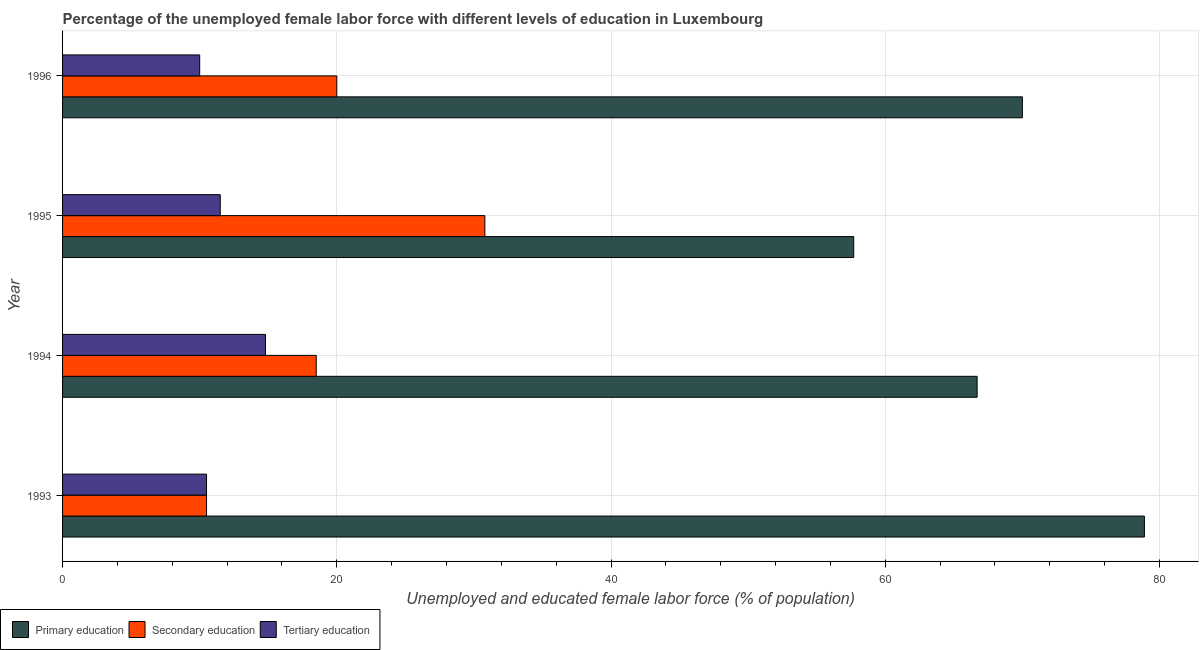How many groups of bars are there?
Offer a terse response. 4. How many bars are there on the 3rd tick from the bottom?
Keep it short and to the point. 3. What is the label of the 2nd group of bars from the top?
Give a very brief answer. 1995. In how many cases, is the number of bars for a given year not equal to the number of legend labels?
Keep it short and to the point. 0. What is the percentage of female labor force who received primary education in 1993?
Give a very brief answer. 78.9. Across all years, what is the maximum percentage of female labor force who received tertiary education?
Provide a succinct answer. 14.8. Across all years, what is the minimum percentage of female labor force who received tertiary education?
Offer a terse response. 10. In which year was the percentage of female labor force who received tertiary education maximum?
Provide a succinct answer. 1994. What is the total percentage of female labor force who received primary education in the graph?
Provide a short and direct response. 273.3. What is the difference between the percentage of female labor force who received primary education in 1994 and the percentage of female labor force who received tertiary education in 1996?
Make the answer very short. 56.7. What is the average percentage of female labor force who received primary education per year?
Provide a short and direct response. 68.33. In the year 1996, what is the difference between the percentage of female labor force who received secondary education and percentage of female labor force who received tertiary education?
Give a very brief answer. 10. In how many years, is the percentage of female labor force who received secondary education greater than 72 %?
Provide a short and direct response. 0. What is the ratio of the percentage of female labor force who received primary education in 1993 to that in 1995?
Offer a very short reply. 1.37. Is the difference between the percentage of female labor force who received secondary education in 1993 and 1994 greater than the difference between the percentage of female labor force who received primary education in 1993 and 1994?
Provide a succinct answer. No. What is the difference between the highest and the second highest percentage of female labor force who received tertiary education?
Ensure brevity in your answer.  3.3. What is the difference between the highest and the lowest percentage of female labor force who received secondary education?
Give a very brief answer. 20.3. In how many years, is the percentage of female labor force who received tertiary education greater than the average percentage of female labor force who received tertiary education taken over all years?
Offer a very short reply. 1. Is the sum of the percentage of female labor force who received secondary education in 1993 and 1994 greater than the maximum percentage of female labor force who received primary education across all years?
Keep it short and to the point. No. What does the 1st bar from the top in 1996 represents?
Make the answer very short. Tertiary education. What does the 3rd bar from the bottom in 1994 represents?
Keep it short and to the point. Tertiary education. Is it the case that in every year, the sum of the percentage of female labor force who received primary education and percentage of female labor force who received secondary education is greater than the percentage of female labor force who received tertiary education?
Offer a very short reply. Yes. How many years are there in the graph?
Your answer should be compact. 4. What is the difference between two consecutive major ticks on the X-axis?
Ensure brevity in your answer.  20. Are the values on the major ticks of X-axis written in scientific E-notation?
Offer a terse response. No. Does the graph contain grids?
Provide a short and direct response. Yes. Where does the legend appear in the graph?
Your answer should be very brief. Bottom left. How many legend labels are there?
Offer a terse response. 3. How are the legend labels stacked?
Offer a very short reply. Horizontal. What is the title of the graph?
Provide a short and direct response. Percentage of the unemployed female labor force with different levels of education in Luxembourg. What is the label or title of the X-axis?
Keep it short and to the point. Unemployed and educated female labor force (% of population). What is the label or title of the Y-axis?
Your answer should be compact. Year. What is the Unemployed and educated female labor force (% of population) in Primary education in 1993?
Make the answer very short. 78.9. What is the Unemployed and educated female labor force (% of population) in Tertiary education in 1993?
Provide a succinct answer. 10.5. What is the Unemployed and educated female labor force (% of population) of Primary education in 1994?
Your response must be concise. 66.7. What is the Unemployed and educated female labor force (% of population) in Tertiary education in 1994?
Your answer should be very brief. 14.8. What is the Unemployed and educated female labor force (% of population) in Primary education in 1995?
Offer a terse response. 57.7. What is the Unemployed and educated female labor force (% of population) of Secondary education in 1995?
Offer a terse response. 30.8. What is the Unemployed and educated female labor force (% of population) of Secondary education in 1996?
Your answer should be very brief. 20. What is the Unemployed and educated female labor force (% of population) of Tertiary education in 1996?
Your response must be concise. 10. Across all years, what is the maximum Unemployed and educated female labor force (% of population) of Primary education?
Offer a terse response. 78.9. Across all years, what is the maximum Unemployed and educated female labor force (% of population) of Secondary education?
Your answer should be very brief. 30.8. Across all years, what is the maximum Unemployed and educated female labor force (% of population) of Tertiary education?
Make the answer very short. 14.8. Across all years, what is the minimum Unemployed and educated female labor force (% of population) in Primary education?
Offer a very short reply. 57.7. Across all years, what is the minimum Unemployed and educated female labor force (% of population) of Secondary education?
Ensure brevity in your answer.  10.5. Across all years, what is the minimum Unemployed and educated female labor force (% of population) in Tertiary education?
Keep it short and to the point. 10. What is the total Unemployed and educated female labor force (% of population) in Primary education in the graph?
Provide a succinct answer. 273.3. What is the total Unemployed and educated female labor force (% of population) of Secondary education in the graph?
Keep it short and to the point. 79.8. What is the total Unemployed and educated female labor force (% of population) in Tertiary education in the graph?
Provide a succinct answer. 46.8. What is the difference between the Unemployed and educated female labor force (% of population) in Secondary education in 1993 and that in 1994?
Provide a short and direct response. -8. What is the difference between the Unemployed and educated female labor force (% of population) of Primary education in 1993 and that in 1995?
Your answer should be compact. 21.2. What is the difference between the Unemployed and educated female labor force (% of population) in Secondary education in 1993 and that in 1995?
Your answer should be very brief. -20.3. What is the difference between the Unemployed and educated female labor force (% of population) in Secondary education in 1993 and that in 1996?
Provide a succinct answer. -9.5. What is the difference between the Unemployed and educated female labor force (% of population) in Primary education in 1994 and that in 1995?
Your answer should be compact. 9. What is the difference between the Unemployed and educated female labor force (% of population) of Tertiary education in 1994 and that in 1995?
Provide a short and direct response. 3.3. What is the difference between the Unemployed and educated female labor force (% of population) of Primary education in 1994 and that in 1996?
Keep it short and to the point. -3.3. What is the difference between the Unemployed and educated female labor force (% of population) in Tertiary education in 1994 and that in 1996?
Make the answer very short. 4.8. What is the difference between the Unemployed and educated female labor force (% of population) in Tertiary education in 1995 and that in 1996?
Ensure brevity in your answer.  1.5. What is the difference between the Unemployed and educated female labor force (% of population) of Primary education in 1993 and the Unemployed and educated female labor force (% of population) of Secondary education in 1994?
Offer a terse response. 60.4. What is the difference between the Unemployed and educated female labor force (% of population) of Primary education in 1993 and the Unemployed and educated female labor force (% of population) of Tertiary education in 1994?
Keep it short and to the point. 64.1. What is the difference between the Unemployed and educated female labor force (% of population) of Primary education in 1993 and the Unemployed and educated female labor force (% of population) of Secondary education in 1995?
Provide a short and direct response. 48.1. What is the difference between the Unemployed and educated female labor force (% of population) in Primary education in 1993 and the Unemployed and educated female labor force (% of population) in Tertiary education in 1995?
Keep it short and to the point. 67.4. What is the difference between the Unemployed and educated female labor force (% of population) in Primary education in 1993 and the Unemployed and educated female labor force (% of population) in Secondary education in 1996?
Give a very brief answer. 58.9. What is the difference between the Unemployed and educated female labor force (% of population) of Primary education in 1993 and the Unemployed and educated female labor force (% of population) of Tertiary education in 1996?
Your answer should be compact. 68.9. What is the difference between the Unemployed and educated female labor force (% of population) of Secondary education in 1993 and the Unemployed and educated female labor force (% of population) of Tertiary education in 1996?
Ensure brevity in your answer.  0.5. What is the difference between the Unemployed and educated female labor force (% of population) of Primary education in 1994 and the Unemployed and educated female labor force (% of population) of Secondary education in 1995?
Keep it short and to the point. 35.9. What is the difference between the Unemployed and educated female labor force (% of population) of Primary education in 1994 and the Unemployed and educated female labor force (% of population) of Tertiary education in 1995?
Make the answer very short. 55.2. What is the difference between the Unemployed and educated female labor force (% of population) in Primary education in 1994 and the Unemployed and educated female labor force (% of population) in Secondary education in 1996?
Keep it short and to the point. 46.7. What is the difference between the Unemployed and educated female labor force (% of population) of Primary education in 1994 and the Unemployed and educated female labor force (% of population) of Tertiary education in 1996?
Offer a terse response. 56.7. What is the difference between the Unemployed and educated female labor force (% of population) of Primary education in 1995 and the Unemployed and educated female labor force (% of population) of Secondary education in 1996?
Offer a terse response. 37.7. What is the difference between the Unemployed and educated female labor force (% of population) in Primary education in 1995 and the Unemployed and educated female labor force (% of population) in Tertiary education in 1996?
Make the answer very short. 47.7. What is the difference between the Unemployed and educated female labor force (% of population) of Secondary education in 1995 and the Unemployed and educated female labor force (% of population) of Tertiary education in 1996?
Give a very brief answer. 20.8. What is the average Unemployed and educated female labor force (% of population) of Primary education per year?
Make the answer very short. 68.33. What is the average Unemployed and educated female labor force (% of population) of Secondary education per year?
Keep it short and to the point. 19.95. In the year 1993, what is the difference between the Unemployed and educated female labor force (% of population) of Primary education and Unemployed and educated female labor force (% of population) of Secondary education?
Your response must be concise. 68.4. In the year 1993, what is the difference between the Unemployed and educated female labor force (% of population) in Primary education and Unemployed and educated female labor force (% of population) in Tertiary education?
Make the answer very short. 68.4. In the year 1993, what is the difference between the Unemployed and educated female labor force (% of population) in Secondary education and Unemployed and educated female labor force (% of population) in Tertiary education?
Ensure brevity in your answer.  0. In the year 1994, what is the difference between the Unemployed and educated female labor force (% of population) of Primary education and Unemployed and educated female labor force (% of population) of Secondary education?
Offer a terse response. 48.2. In the year 1994, what is the difference between the Unemployed and educated female labor force (% of population) of Primary education and Unemployed and educated female labor force (% of population) of Tertiary education?
Keep it short and to the point. 51.9. In the year 1995, what is the difference between the Unemployed and educated female labor force (% of population) of Primary education and Unemployed and educated female labor force (% of population) of Secondary education?
Your answer should be compact. 26.9. In the year 1995, what is the difference between the Unemployed and educated female labor force (% of population) of Primary education and Unemployed and educated female labor force (% of population) of Tertiary education?
Provide a short and direct response. 46.2. In the year 1995, what is the difference between the Unemployed and educated female labor force (% of population) in Secondary education and Unemployed and educated female labor force (% of population) in Tertiary education?
Ensure brevity in your answer.  19.3. In the year 1996, what is the difference between the Unemployed and educated female labor force (% of population) in Primary education and Unemployed and educated female labor force (% of population) in Secondary education?
Offer a terse response. 50. In the year 1996, what is the difference between the Unemployed and educated female labor force (% of population) in Primary education and Unemployed and educated female labor force (% of population) in Tertiary education?
Your answer should be very brief. 60. What is the ratio of the Unemployed and educated female labor force (% of population) in Primary education in 1993 to that in 1994?
Your response must be concise. 1.18. What is the ratio of the Unemployed and educated female labor force (% of population) in Secondary education in 1993 to that in 1994?
Offer a terse response. 0.57. What is the ratio of the Unemployed and educated female labor force (% of population) of Tertiary education in 1993 to that in 1994?
Ensure brevity in your answer.  0.71. What is the ratio of the Unemployed and educated female labor force (% of population) in Primary education in 1993 to that in 1995?
Provide a succinct answer. 1.37. What is the ratio of the Unemployed and educated female labor force (% of population) in Secondary education in 1993 to that in 1995?
Make the answer very short. 0.34. What is the ratio of the Unemployed and educated female labor force (% of population) of Primary education in 1993 to that in 1996?
Provide a short and direct response. 1.13. What is the ratio of the Unemployed and educated female labor force (% of population) in Secondary education in 1993 to that in 1996?
Provide a succinct answer. 0.53. What is the ratio of the Unemployed and educated female labor force (% of population) of Tertiary education in 1993 to that in 1996?
Offer a terse response. 1.05. What is the ratio of the Unemployed and educated female labor force (% of population) of Primary education in 1994 to that in 1995?
Keep it short and to the point. 1.16. What is the ratio of the Unemployed and educated female labor force (% of population) of Secondary education in 1994 to that in 1995?
Offer a terse response. 0.6. What is the ratio of the Unemployed and educated female labor force (% of population) of Tertiary education in 1994 to that in 1995?
Make the answer very short. 1.29. What is the ratio of the Unemployed and educated female labor force (% of population) of Primary education in 1994 to that in 1996?
Your response must be concise. 0.95. What is the ratio of the Unemployed and educated female labor force (% of population) in Secondary education in 1994 to that in 1996?
Provide a succinct answer. 0.93. What is the ratio of the Unemployed and educated female labor force (% of population) in Tertiary education in 1994 to that in 1996?
Provide a succinct answer. 1.48. What is the ratio of the Unemployed and educated female labor force (% of population) of Primary education in 1995 to that in 1996?
Your answer should be compact. 0.82. What is the ratio of the Unemployed and educated female labor force (% of population) of Secondary education in 1995 to that in 1996?
Your response must be concise. 1.54. What is the ratio of the Unemployed and educated female labor force (% of population) in Tertiary education in 1995 to that in 1996?
Your answer should be compact. 1.15. What is the difference between the highest and the second highest Unemployed and educated female labor force (% of population) of Primary education?
Provide a short and direct response. 8.9. What is the difference between the highest and the lowest Unemployed and educated female labor force (% of population) of Primary education?
Provide a short and direct response. 21.2. What is the difference between the highest and the lowest Unemployed and educated female labor force (% of population) in Secondary education?
Offer a very short reply. 20.3. 